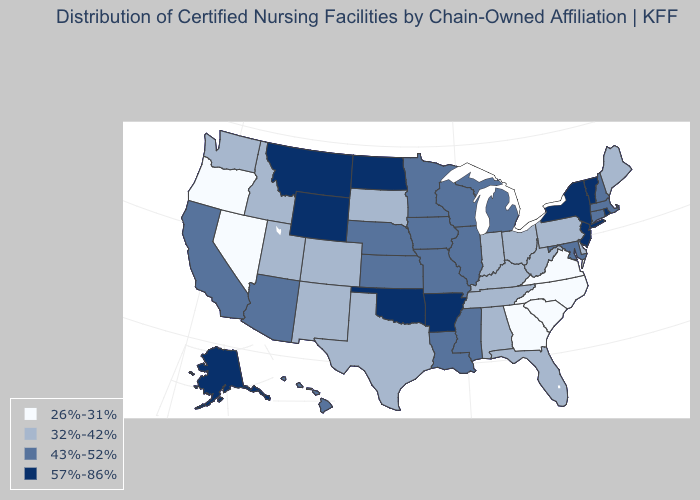Name the states that have a value in the range 32%-42%?
Short answer required. Alabama, Colorado, Delaware, Florida, Idaho, Indiana, Kentucky, Maine, New Mexico, Ohio, Pennsylvania, South Dakota, Tennessee, Texas, Utah, Washington, West Virginia. Which states have the highest value in the USA?
Give a very brief answer. Alaska, Arkansas, Montana, New Jersey, New York, North Dakota, Oklahoma, Rhode Island, Vermont, Wyoming. Among the states that border West Virginia , does Ohio have the lowest value?
Write a very short answer. No. Among the states that border Maryland , does Virginia have the highest value?
Keep it brief. No. Does California have the highest value in the USA?
Give a very brief answer. No. What is the highest value in states that border Mississippi?
Answer briefly. 57%-86%. What is the value of New Hampshire?
Give a very brief answer. 43%-52%. What is the value of Arkansas?
Answer briefly. 57%-86%. What is the lowest value in the USA?
Concise answer only. 26%-31%. Among the states that border Illinois , which have the highest value?
Quick response, please. Iowa, Missouri, Wisconsin. Does New Mexico have the lowest value in the USA?
Write a very short answer. No. Does South Carolina have the lowest value in the USA?
Be succinct. Yes. Which states have the lowest value in the USA?
Give a very brief answer. Georgia, Nevada, North Carolina, Oregon, South Carolina, Virginia. What is the lowest value in the USA?
Give a very brief answer. 26%-31%. Name the states that have a value in the range 26%-31%?
Write a very short answer. Georgia, Nevada, North Carolina, Oregon, South Carolina, Virginia. 